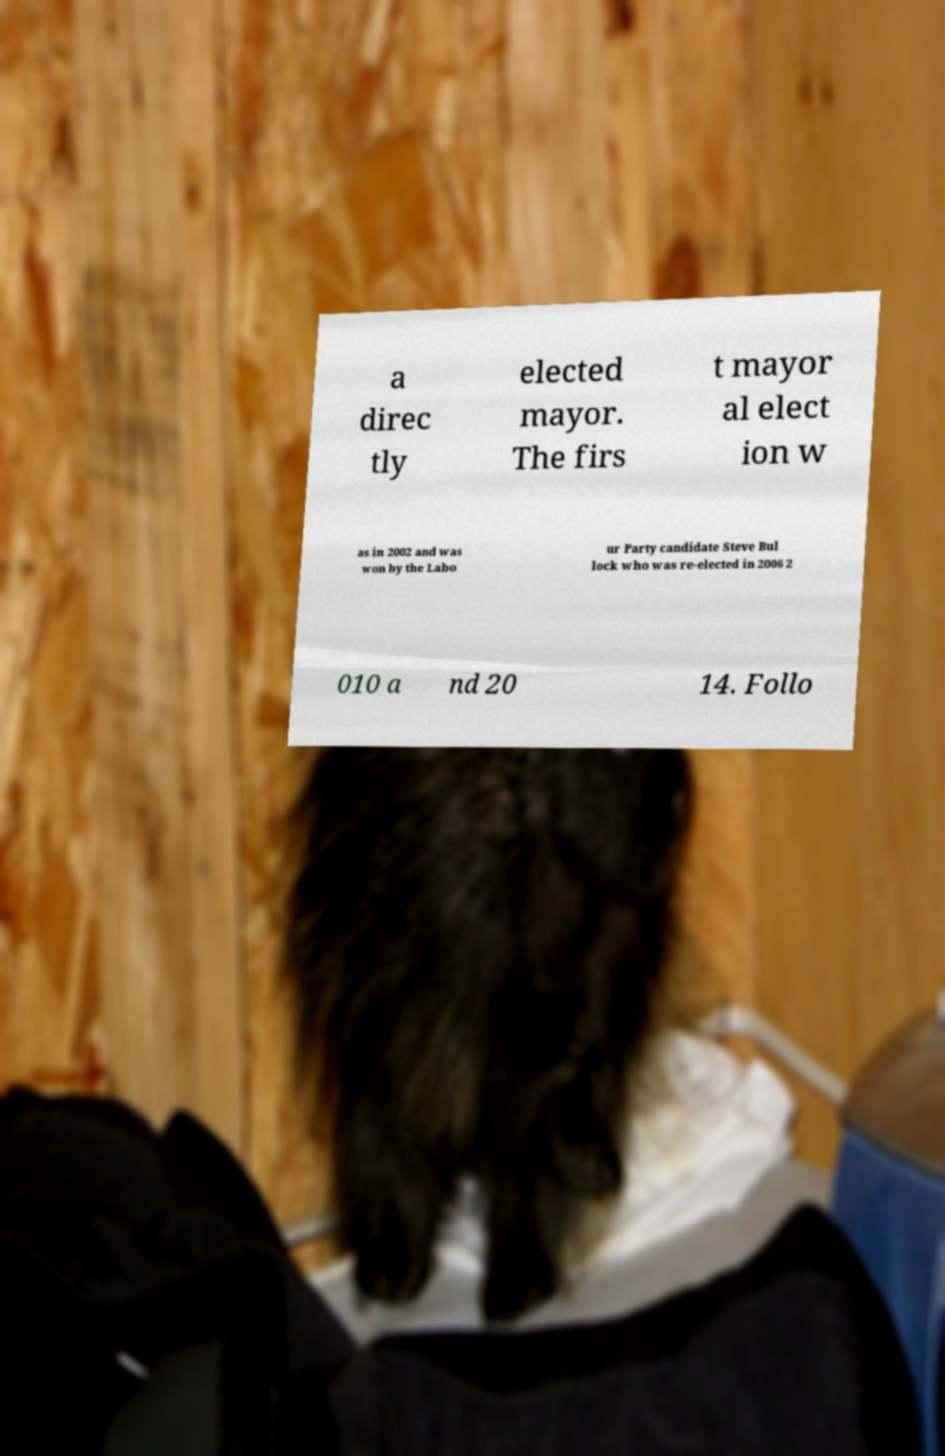Could you assist in decoding the text presented in this image and type it out clearly? a direc tly elected mayor. The firs t mayor al elect ion w as in 2002 and was won by the Labo ur Party candidate Steve Bul lock who was re-elected in 2006 2 010 a nd 20 14. Follo 